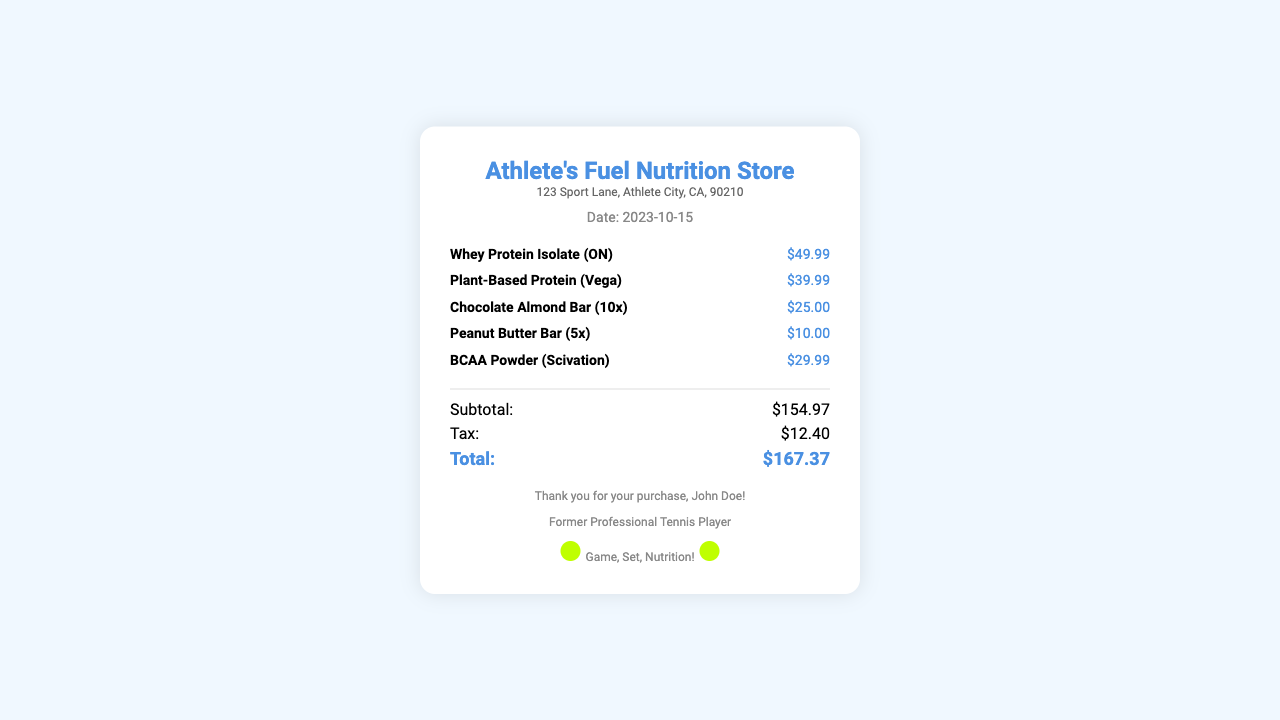What is the date of the purchase? The date is clearly stated in the document header, showing when the transaction took place, which is 2023-10-15.
Answer: 2023-10-15 What is the name of the store? The store's name is prominently displayed at the top of the document, indicating where the purchase was made.
Answer: Athlete's Fuel Nutrition Store How much did the Whey Protein Isolate cost? The price for the Whey Protein Isolate is specified next to the item in the document, indicating its individual cost.
Answer: $49.99 What is the total amount of tax applied? The subtotal and tax information are provided in the totals section, showing how much tax was charged for the purchase.
Answer: $12.40 What is the total cost of the items purchased? The total reflects the final amount to be paid after including all items and tax, providing a summary of the total cost for the buyer.
Answer: $167.37 How many Chocolate Almond Bars were purchased? The item description includes the quantity packaged in the box, indicating how many were bought in that transaction.
Answer: 10x What is the subtotal before tax? The subtotal provides the total of all items listed before tax is added, summarizing the initial cost.
Answer: $154.97 Who is the customer that made this purchase? The customer's name is provided in the footer, acknowledging who made the transaction at the store.
Answer: John Doe What type of protein is the Plant-Based Protein? The name of the protein product implies its source, describing what kind of protein it is categorized under.
Answer: Plant-Based What is the brand of the BCAA Powder? The brand of the BCAA Powder is mentioned next to the product name, revealing the manufacturer associated with the item.
Answer: Scivation 